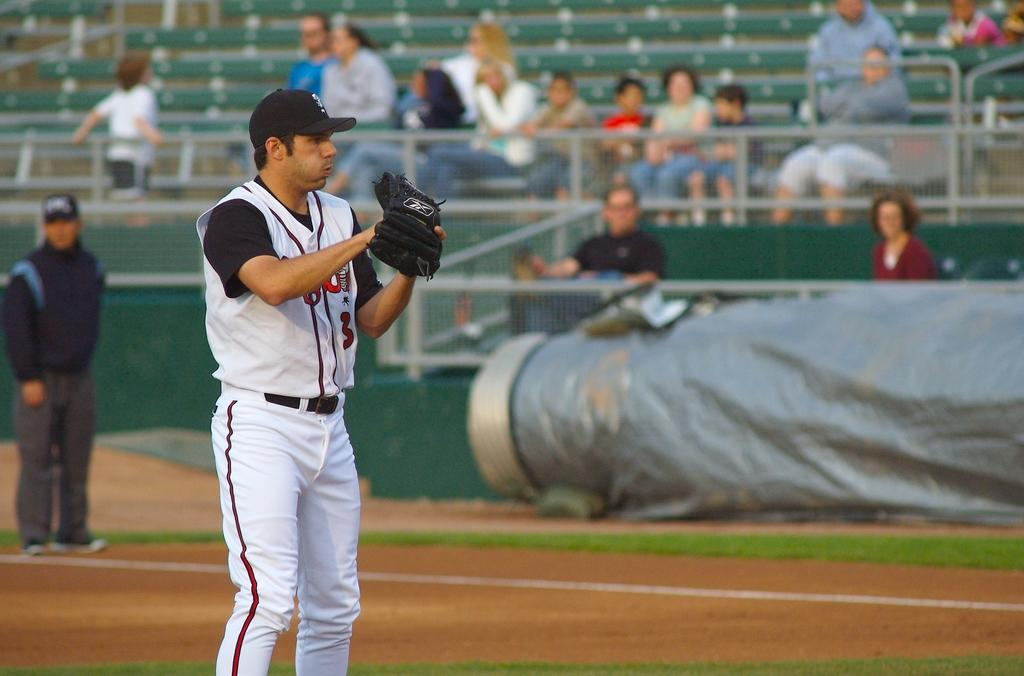What is the man in the image doing? The man is standing on the ground in the image. What is the man wearing on his hand? The man is wearing a glove. What can be seen in the background of the image? There are people, a fence, chairs, and an object in the background of the image. What type of list can be seen on the chairs in the image? There is no list present in the image, and the chairs do not have any visible writing or objects on them. 